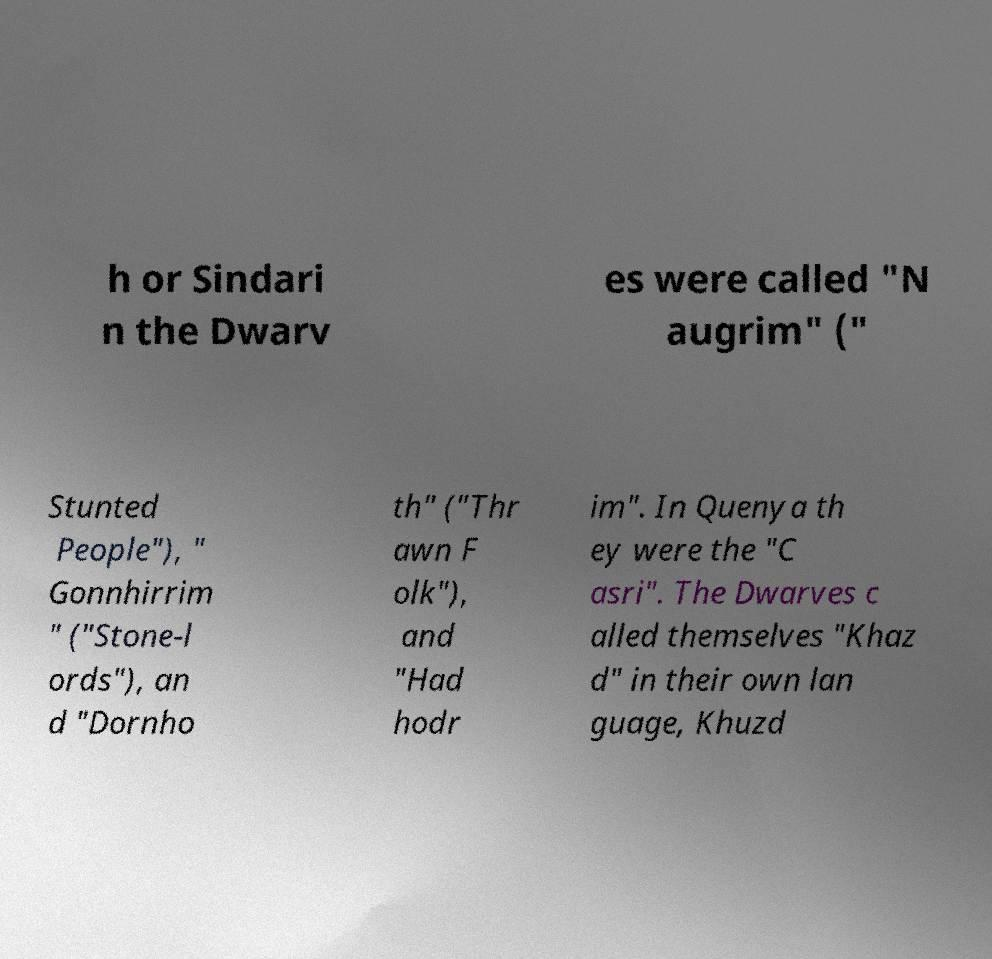For documentation purposes, I need the text within this image transcribed. Could you provide that? h or Sindari n the Dwarv es were called "N augrim" (" Stunted People"), " Gonnhirrim " ("Stone-l ords"), an d "Dornho th" ("Thr awn F olk"), and "Had hodr im". In Quenya th ey were the "C asri". The Dwarves c alled themselves "Khaz d" in their own lan guage, Khuzd 